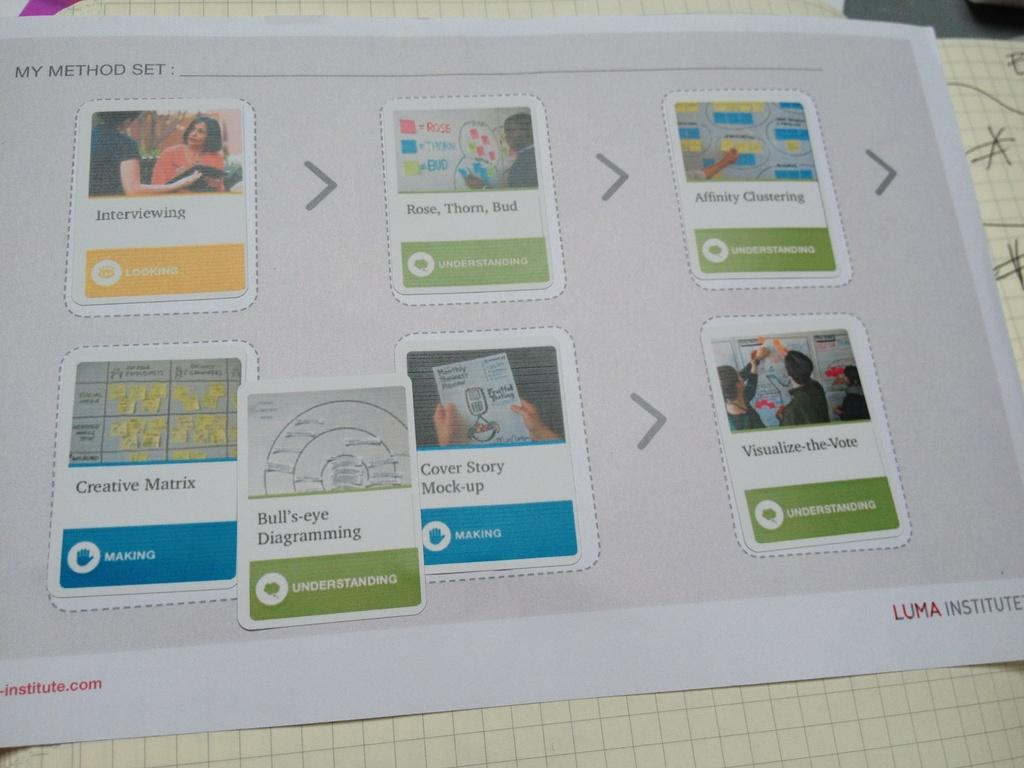What is the main object in the image? There is a paper in the image. What can be found on the paper? The paper contains images of people, symbols, and text. What type of apple is being used as a brick in the image? There is no apple or brick present in the image; the image only contains a paper with images of people, symbols, and text. 